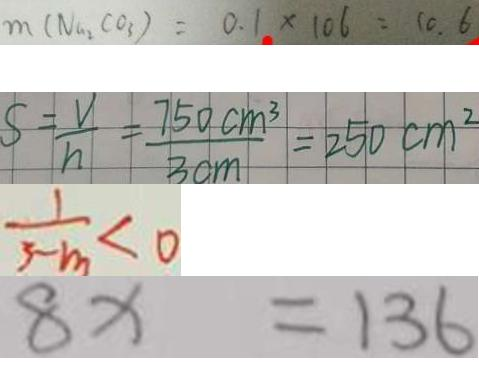<formula> <loc_0><loc_0><loc_500><loc_500>m ( N a _ { 2 } C O _ { 3 } ) = 0 . 1 \times 1 0 6 = 1 0 . 6 
 S = \frac { V } { h } = \frac { 7 5 0 c m ^ { 3 } } { 3 c m } = 2 5 0 c m ^ { 2 } 
 \frac { 1 } { 3 - m } < 0 
 8 x = 1 3 6</formula> 